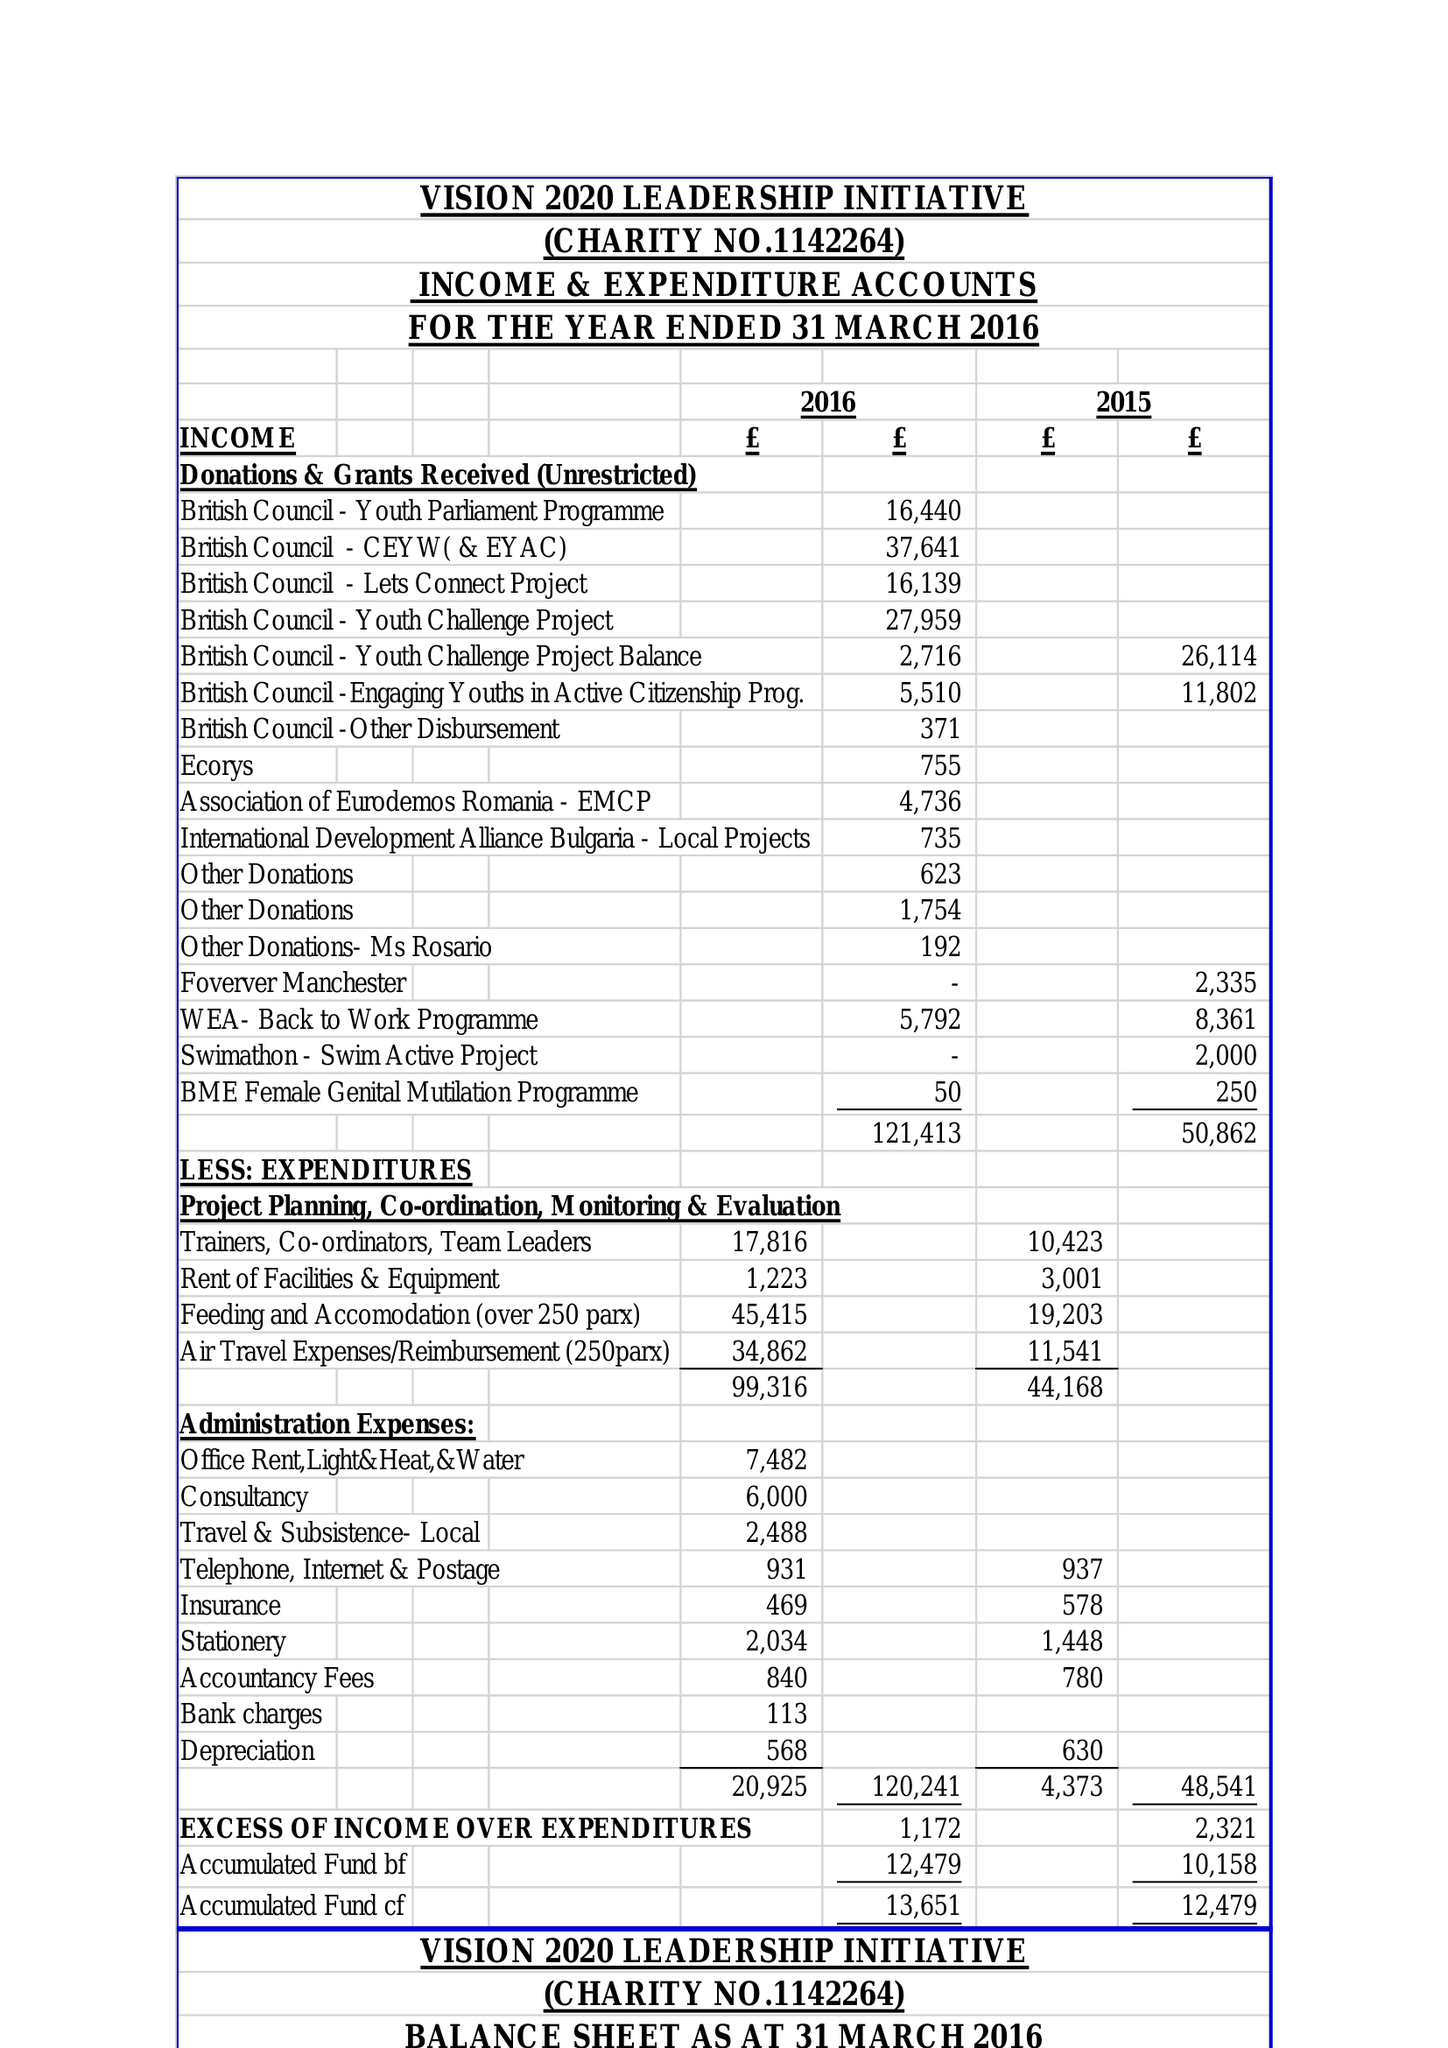What is the value for the report_date?
Answer the question using a single word or phrase. 2016-03-31 